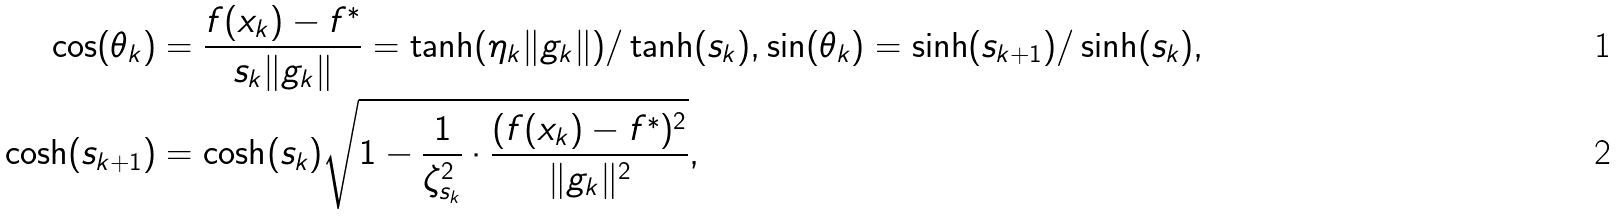<formula> <loc_0><loc_0><loc_500><loc_500>\cos ( \theta _ { k } ) & = \frac { f ( x _ { k } ) - f ^ { * } } { s _ { k } \| g _ { k } \| } = \tanh ( \eta _ { k } \| g _ { k } \| ) / \tanh ( s _ { k } ) , \sin ( \theta _ { k } ) = \sinh ( s _ { k + 1 } ) / \sinh ( s _ { k } ) , \\ \cosh ( s _ { k + 1 } ) & = \cosh ( s _ { k } ) \sqrt { 1 - \frac { 1 } { \zeta _ { s _ { k } } ^ { 2 } } \cdot \frac { ( f ( x _ { k } ) - f ^ { * } ) ^ { 2 } } { \| g _ { k } \| ^ { 2 } } } ,</formula> 